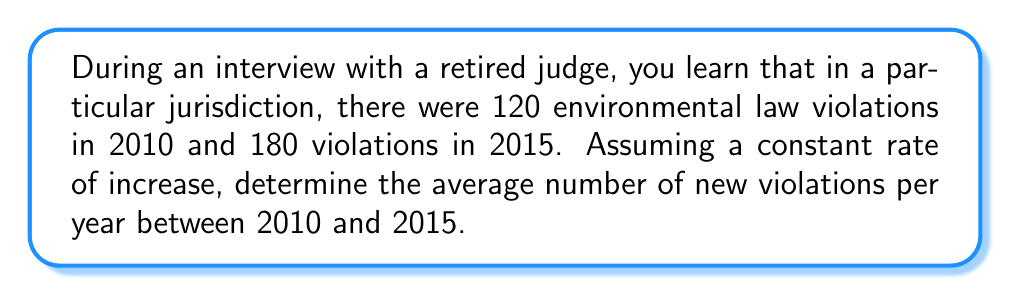Give your solution to this math problem. To solve this problem, we'll follow these steps:

1. Calculate the total increase in violations:
   $180 - 120 = 60$ violations

2. Determine the time period:
   $2015 - 2010 = 5$ years

3. Calculate the rate of increase per year:
   $$\text{Rate} = \frac{\text{Total increase}}{\text{Time period}}$$
   $$\text{Rate} = \frac{60 \text{ violations}}{5 \text{ years}}$$
   $$\text{Rate} = 12 \text{ violations per year}$$

This means that, on average, there were 12 new environmental law violations each year between 2010 and 2015.
Answer: 12 violations/year 